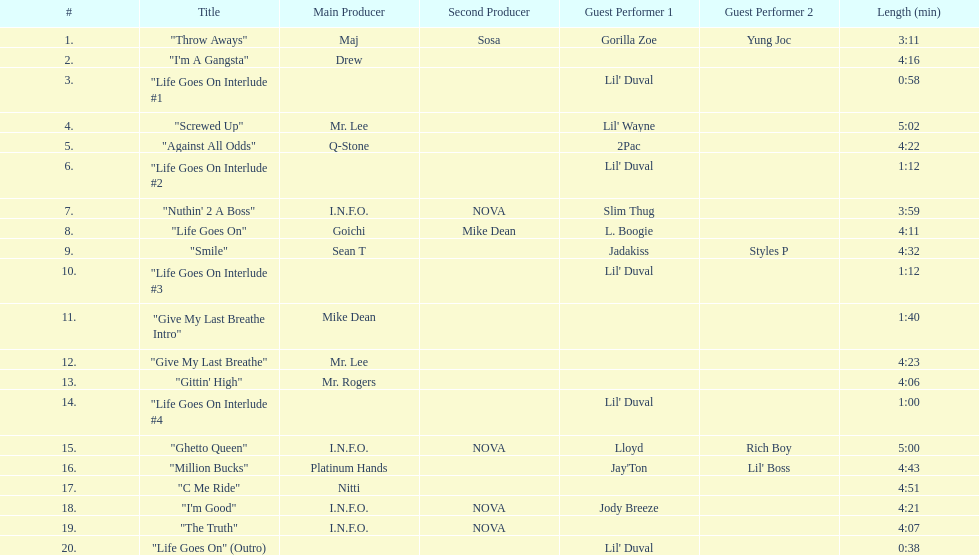What is the longest track on the album? "Screwed Up". 